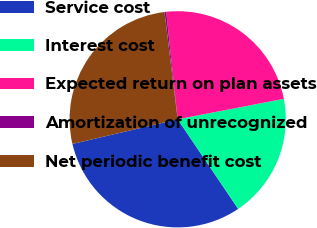<chart> <loc_0><loc_0><loc_500><loc_500><pie_chart><fcel>Service cost<fcel>Interest cost<fcel>Expected return on plan assets<fcel>Amortization of unrecognized<fcel>Net periodic benefit cost<nl><fcel>30.79%<fcel>18.58%<fcel>23.66%<fcel>0.25%<fcel>26.72%<nl></chart> 